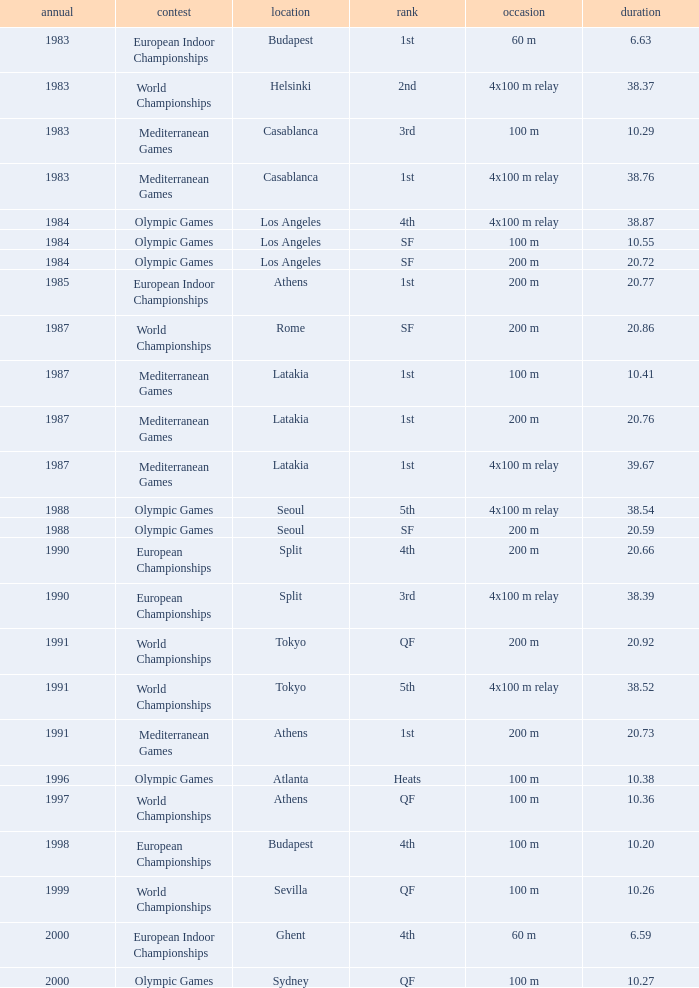What Position has a Time of 20.66? 4th. 